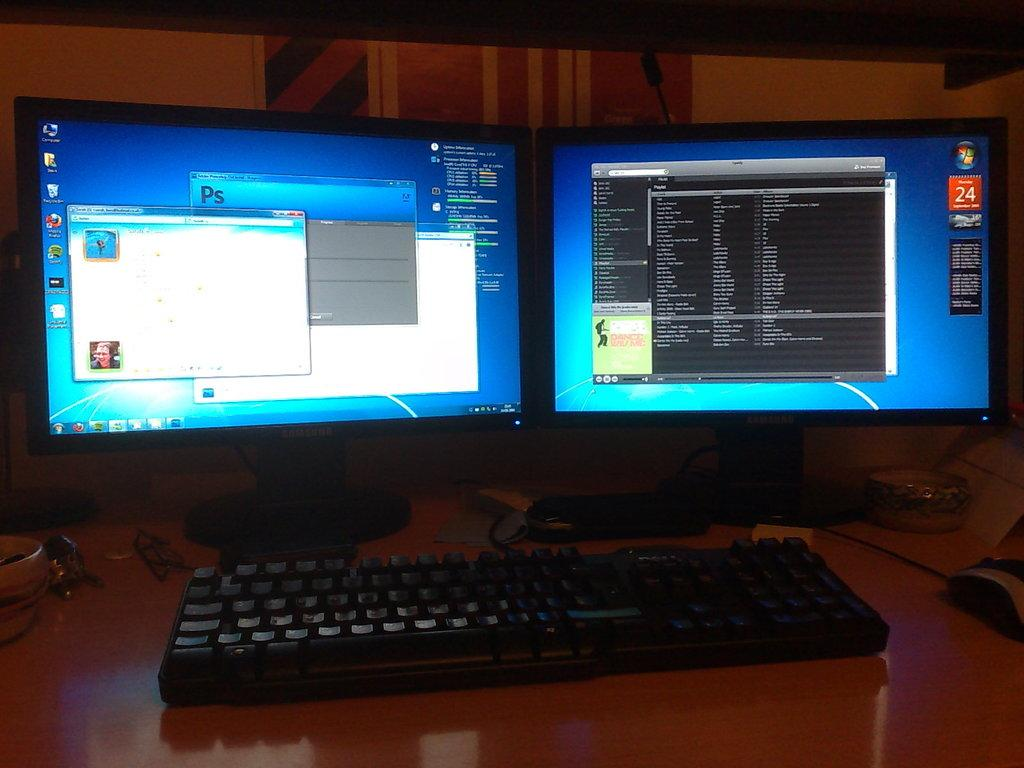<image>
Relay a brief, clear account of the picture shown. Among the icons displayed on the left monitor is Mozilla Firefox. 